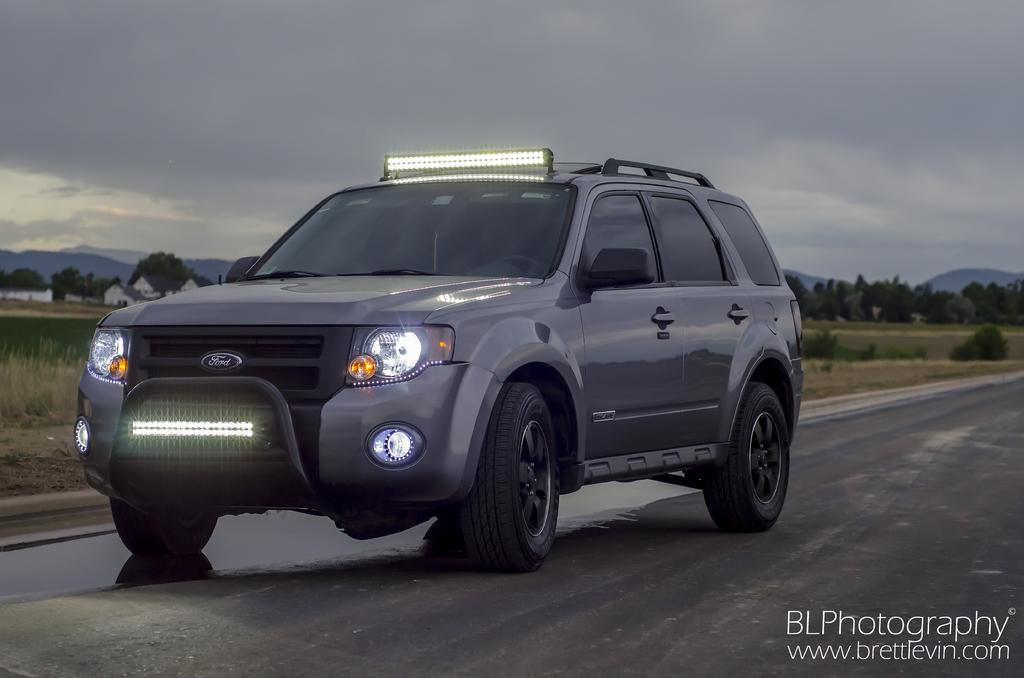What is the main subject of the image? There is a car on the road in the image. What can be seen in the background of the image? There are trees and grass visible in the background of the image. How many crates are stacked on the tongue of the car in the image? There is no crate or tongue present on the car in the image. 